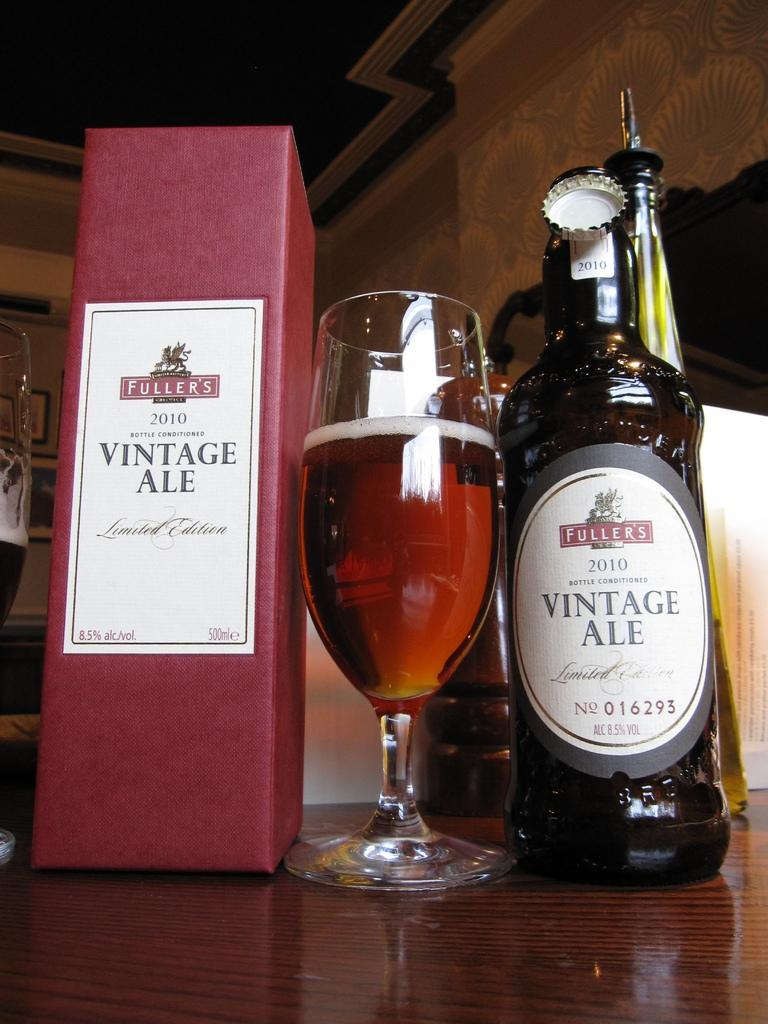<image>
Share a concise interpretation of the image provided. bottle of wine from vintage ale and glass ready to be served 